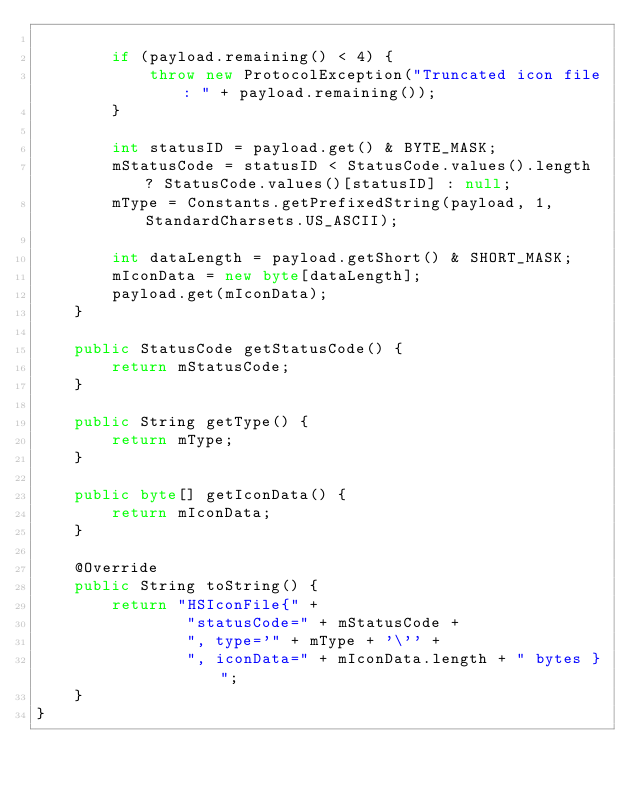<code> <loc_0><loc_0><loc_500><loc_500><_Java_>
        if (payload.remaining() < 4) {
            throw new ProtocolException("Truncated icon file: " + payload.remaining());
        }

        int statusID = payload.get() & BYTE_MASK;
        mStatusCode = statusID < StatusCode.values().length ? StatusCode.values()[statusID] : null;
        mType = Constants.getPrefixedString(payload, 1, StandardCharsets.US_ASCII);

        int dataLength = payload.getShort() & SHORT_MASK;
        mIconData = new byte[dataLength];
        payload.get(mIconData);
    }

    public StatusCode getStatusCode() {
        return mStatusCode;
    }

    public String getType() {
        return mType;
    }

    public byte[] getIconData() {
        return mIconData;
    }

    @Override
    public String toString() {
        return "HSIconFile{" +
                "statusCode=" + mStatusCode +
                ", type='" + mType + '\'' +
                ", iconData=" + mIconData.length + " bytes }";
    }
}
</code> 